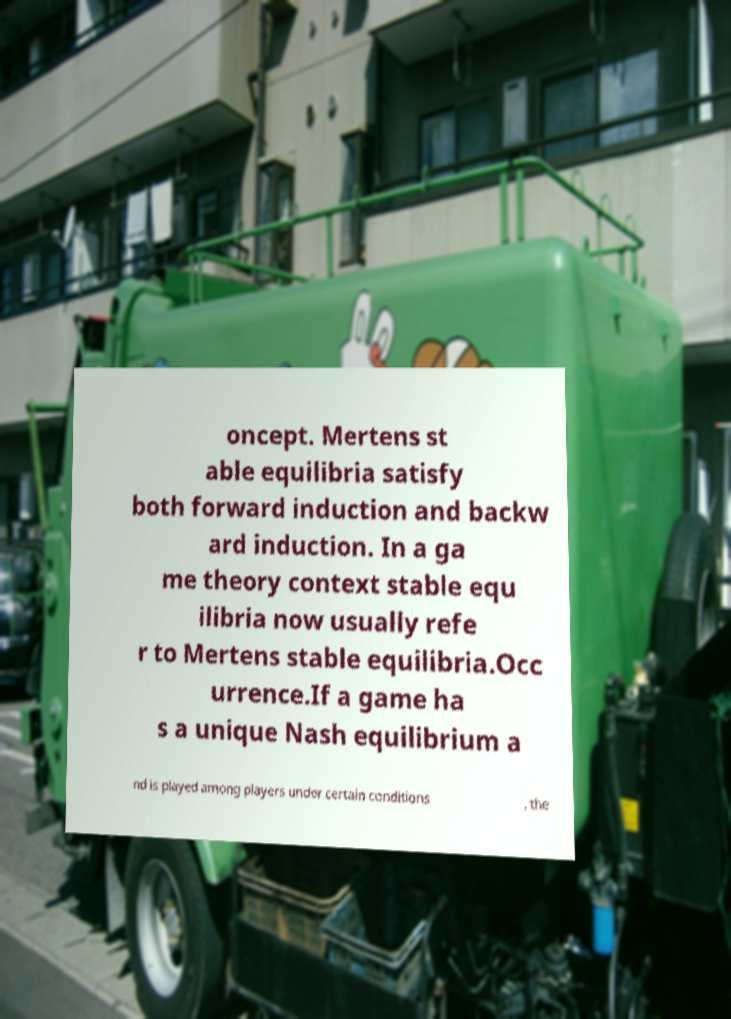Can you read and provide the text displayed in the image?This photo seems to have some interesting text. Can you extract and type it out for me? oncept. Mertens st able equilibria satisfy both forward induction and backw ard induction. In a ga me theory context stable equ ilibria now usually refe r to Mertens stable equilibria.Occ urrence.If a game ha s a unique Nash equilibrium a nd is played among players under certain conditions , the 